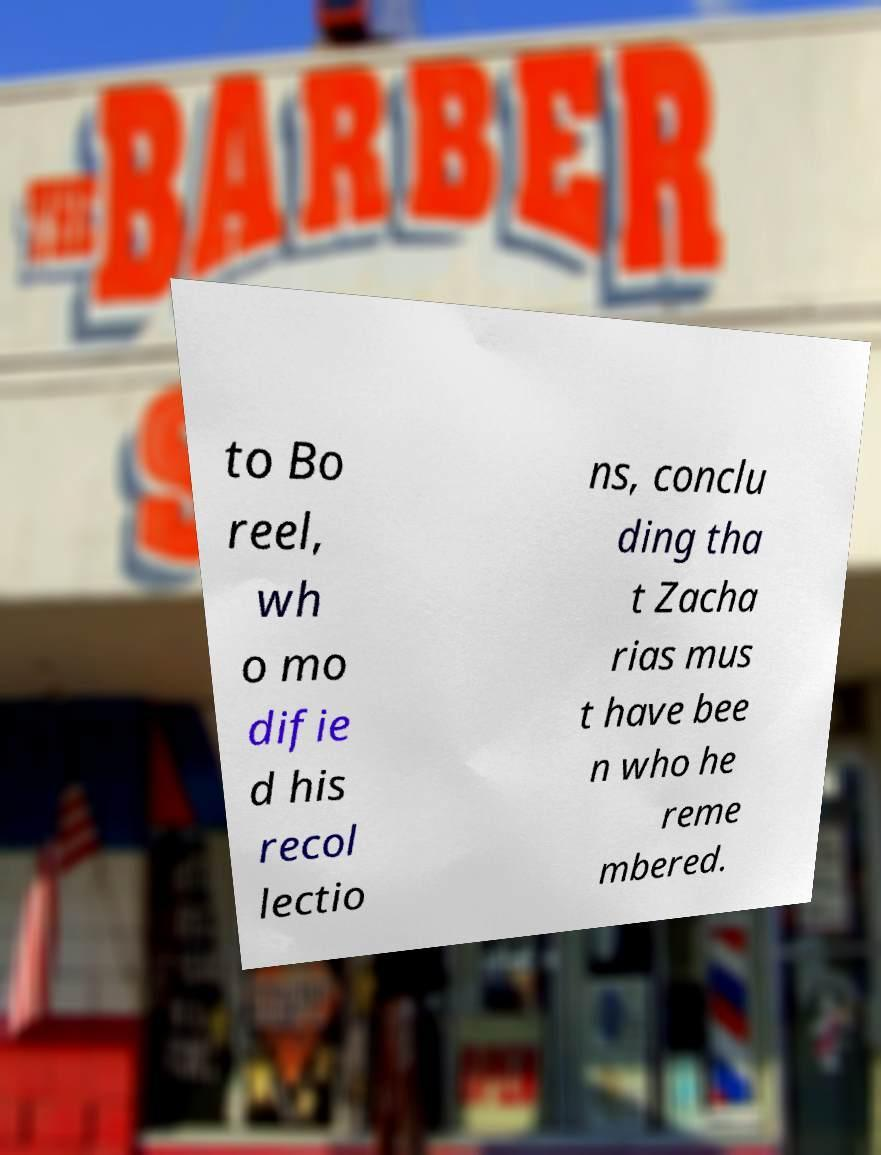Please read and relay the text visible in this image. What does it say? to Bo reel, wh o mo difie d his recol lectio ns, conclu ding tha t Zacha rias mus t have bee n who he reme mbered. 